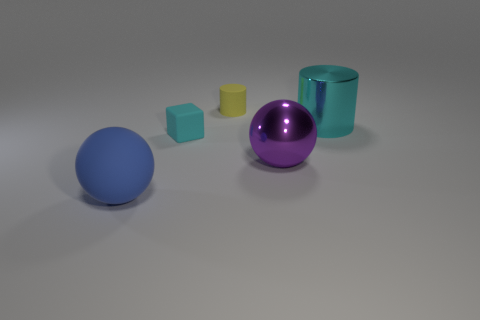Are there any large blue rubber spheres?
Your response must be concise. Yes. Does the object right of the big metal sphere have the same material as the big ball right of the yellow rubber cylinder?
Make the answer very short. Yes. The metal thing that is the same color as the matte block is what shape?
Keep it short and to the point. Cylinder. What number of things are either objects on the right side of the tiny cylinder or objects that are left of the large cyan shiny thing?
Your answer should be very brief. 5. Do the large metallic object to the right of the purple metallic object and the small matte object in front of the yellow thing have the same color?
Offer a very short reply. Yes. What is the shape of the rubber object that is both right of the big rubber thing and in front of the cyan shiny cylinder?
Offer a terse response. Cube. The cylinder that is the same size as the blue object is what color?
Ensure brevity in your answer.  Cyan. Is there a large matte ball that has the same color as the small cylinder?
Keep it short and to the point. No. Is the size of the ball in front of the large shiny sphere the same as the cylinder that is in front of the yellow matte object?
Ensure brevity in your answer.  Yes. What material is the thing that is on the right side of the yellow cylinder and behind the cyan matte thing?
Provide a succinct answer. Metal. 